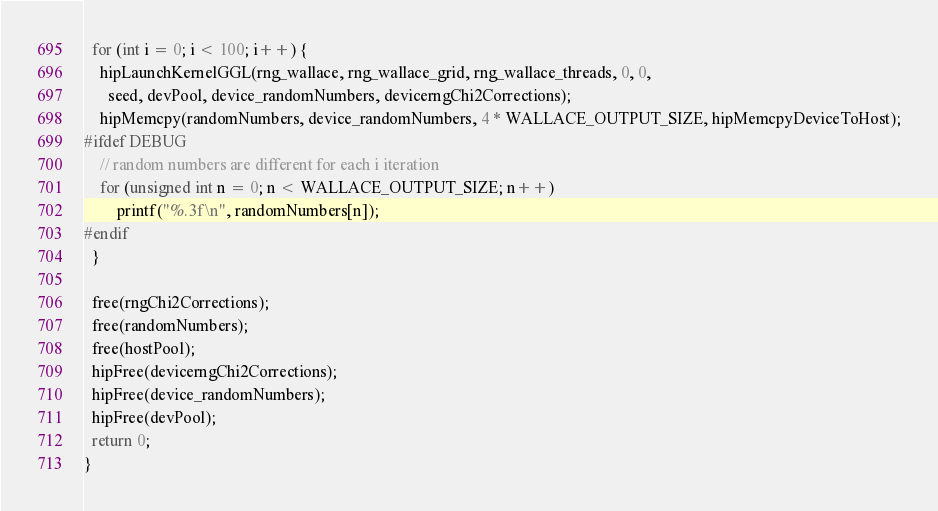<code> <loc_0><loc_0><loc_500><loc_500><_Cuda_>  for (int i = 0; i < 100; i++) {
    hipLaunchKernelGGL(rng_wallace, rng_wallace_grid, rng_wallace_threads, 0, 0, 
      seed, devPool, device_randomNumbers, devicerngChi2Corrections);
    hipMemcpy(randomNumbers, device_randomNumbers, 4 * WALLACE_OUTPUT_SIZE, hipMemcpyDeviceToHost);
#ifdef DEBUG
    // random numbers are different for each i iteration 
    for (unsigned int n = 0; n < WALLACE_OUTPUT_SIZE; n++) 
    	printf("%.3f\n", randomNumbers[n]);
#endif
  }
  
  free(rngChi2Corrections);
  free(randomNumbers);
  free(hostPool);
  hipFree(devicerngChi2Corrections);
  hipFree(device_randomNumbers);
  hipFree(devPool);
  return 0;
}
</code> 